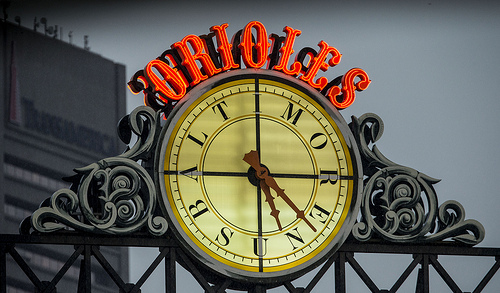What time does the clock in the image show? The clock hands indicate a time of approximately 8:50. 